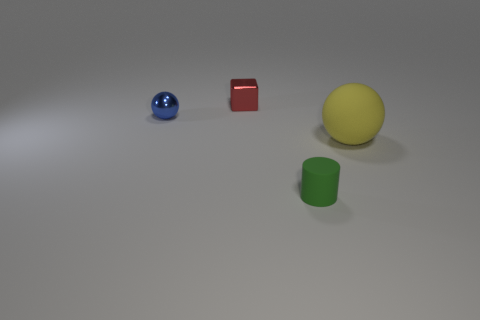Are there any other things that are the same size as the yellow matte thing?
Your answer should be compact. No. There is a rubber thing that is left of the object to the right of the tiny green rubber cylinder; what size is it?
Your answer should be compact. Small. Is the number of yellow spheres that are behind the red shiny cube less than the number of small blue spheres that are on the right side of the small metallic ball?
Your response must be concise. No. Is the color of the ball that is to the right of the small sphere the same as the thing in front of the yellow rubber sphere?
Your response must be concise. No. The thing that is in front of the shiny ball and behind the green rubber cylinder is made of what material?
Keep it short and to the point. Rubber. Is there a big brown shiny cube?
Your response must be concise. No. There is a blue object that is made of the same material as the cube; what shape is it?
Make the answer very short. Sphere. There is a large rubber thing; does it have the same shape as the metallic thing in front of the red shiny thing?
Offer a very short reply. Yes. What is the material of the thing that is in front of the object that is to the right of the tiny green cylinder?
Provide a short and direct response. Rubber. What number of other things are the same shape as the small green object?
Provide a succinct answer. 0. 